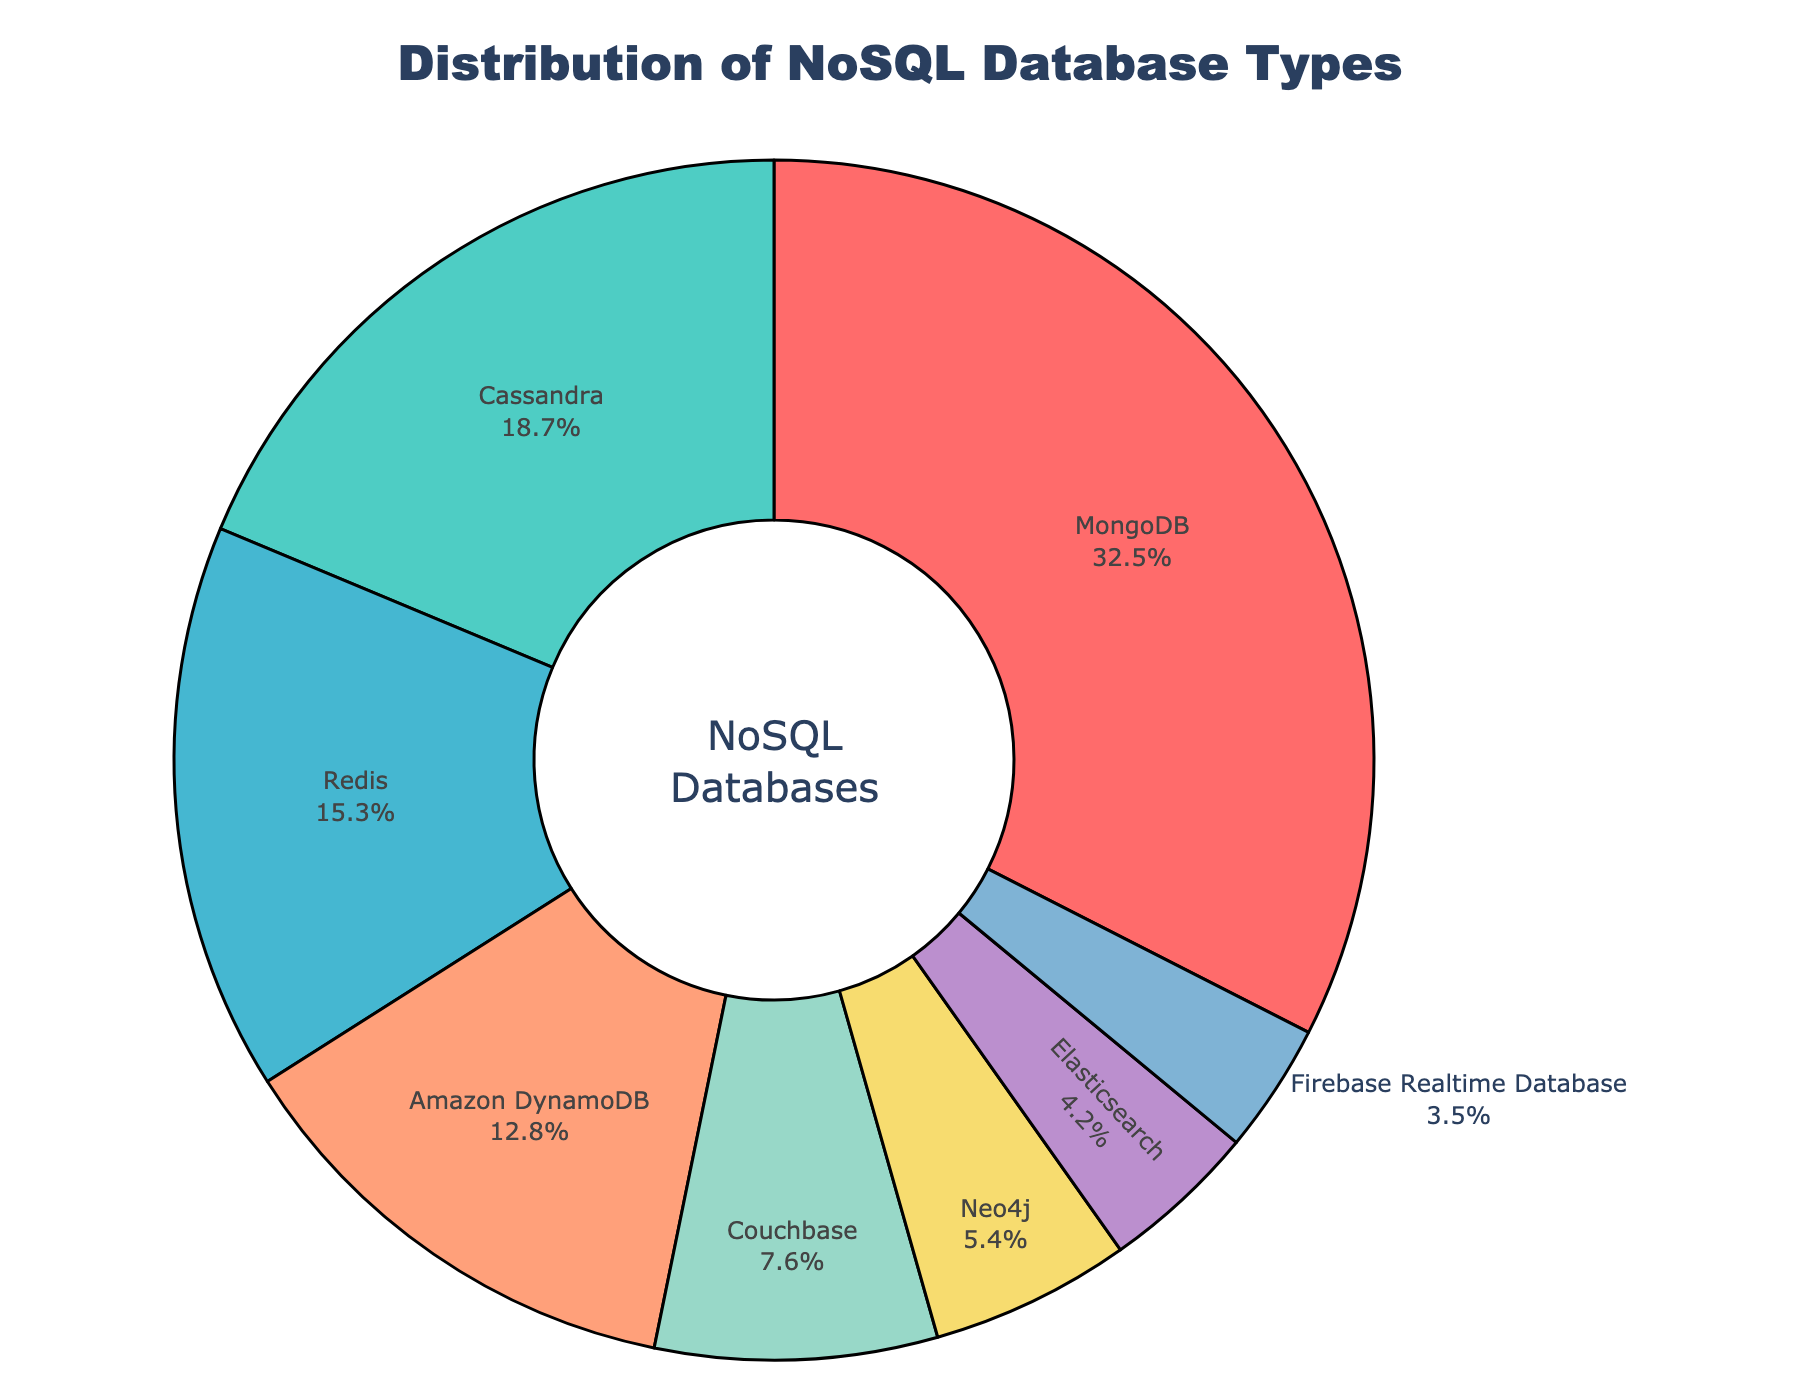What is the most widely used NoSQL database according to the chart? The chart shows that the largest portion of the donut chart corresponds to MongoDB.
Answer: MongoDB Which NoSQL database type has the second highest usage? The second largest segment in the chart is Cassandra.
Answer: Cassandra What is the combined percentage of MongoDB and Redis usage? MongoDB accounts for 32.5% and Redis for 15.3%. Adding these percentages, 32.5 + 15.3 = 47.8%.
Answer: 47.8% Is the percentage of Amazon DynamoDB usage greater than that of Couchbase? Amazon DynamoDB has a percentage of 12.8%, while Couchbase has 7.6%. 12.8% > 7.6%.
Answer: Yes If you sum the usage percentages of Elasticsearch and Couchbase, what do you get? Elasticsearch is 4.2% and Couchbase is 7.6%. Adding these together gives 4.2 + 7.6 = 11.8%.
Answer: 11.8% Which NoSQL database type has the least usage according to the chart? The smallest segment in the chart represents Firebase Realtime Database at 3.5%.
Answer: Firebase Realtime Database By how much does MongoDB usage exceed the combined usage of Elasticsearch and Neo4j? MongoDB usage is 32.5%. Combining Elasticsearch and Neo4j usage gives 4.2 + 5.4 = 9.6%. The difference is 32.5 - 9.6 = 22.9%.
Answer: 22.9% What percentage of NoSQL usage is covered by databases other than MongoDB and Redis? MongoDB and Redis together account for 32.5 + 15.3 = 47.8%. Subtracting from 100% gives 100 - 47.8 = 52.2%.
Answer: 52.2% What color represents the segment for Cassandra in the chart? The segment for Cassandra is shown in green.
Answer: Green 